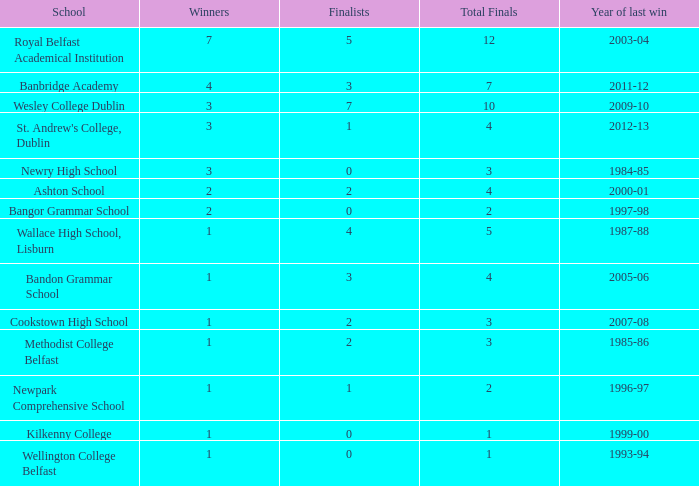Which educational institution experienced its latest success in the 2007-08 school year? Cookstown High School. 